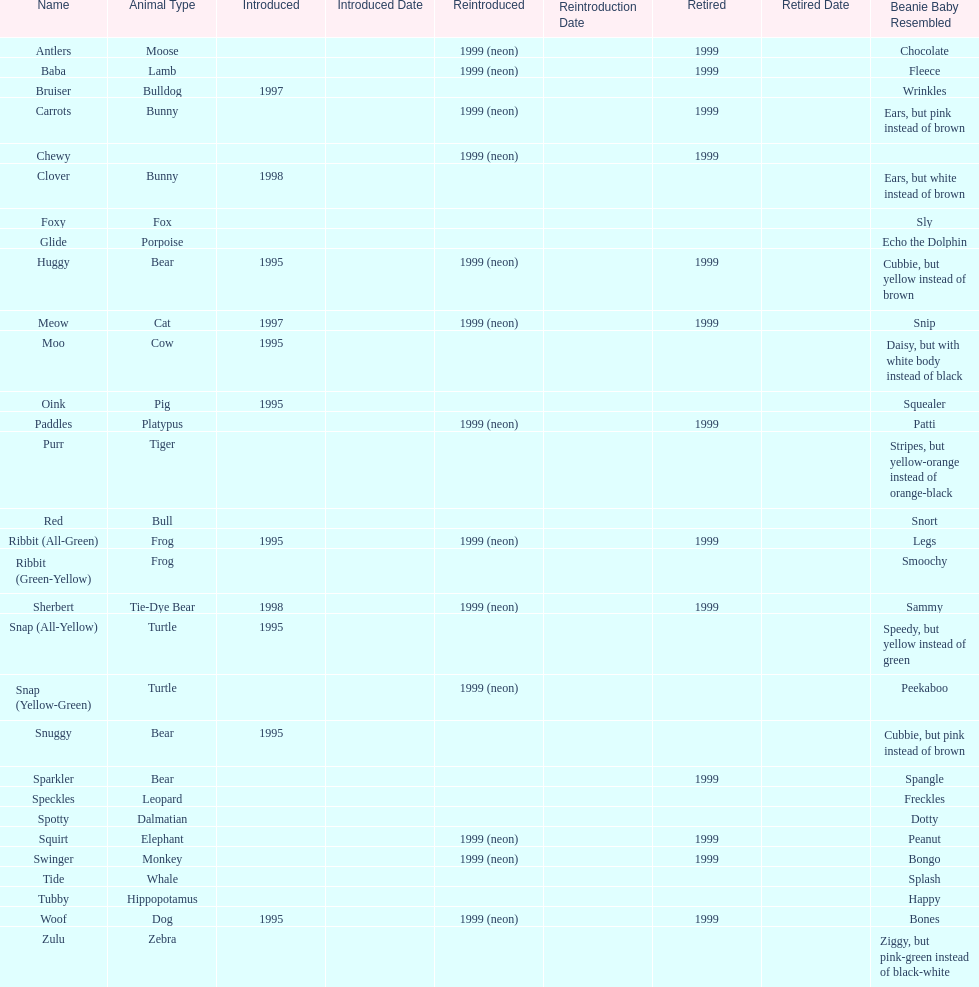What is the total number of pillow pals that were reintroduced as a neon variety? 13. 